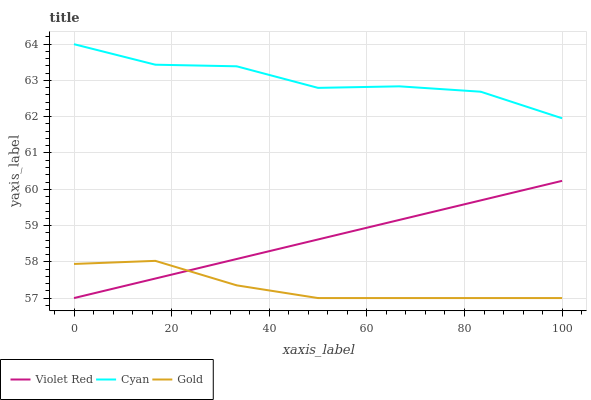Does Gold have the minimum area under the curve?
Answer yes or no. Yes. Does Cyan have the maximum area under the curve?
Answer yes or no. Yes. Does Violet Red have the minimum area under the curve?
Answer yes or no. No. Does Violet Red have the maximum area under the curve?
Answer yes or no. No. Is Violet Red the smoothest?
Answer yes or no. Yes. Is Cyan the roughest?
Answer yes or no. Yes. Is Gold the smoothest?
Answer yes or no. No. Is Gold the roughest?
Answer yes or no. No. Does Violet Red have the lowest value?
Answer yes or no. Yes. Does Cyan have the highest value?
Answer yes or no. Yes. Does Violet Red have the highest value?
Answer yes or no. No. Is Gold less than Cyan?
Answer yes or no. Yes. Is Cyan greater than Gold?
Answer yes or no. Yes. Does Violet Red intersect Gold?
Answer yes or no. Yes. Is Violet Red less than Gold?
Answer yes or no. No. Is Violet Red greater than Gold?
Answer yes or no. No. Does Gold intersect Cyan?
Answer yes or no. No. 